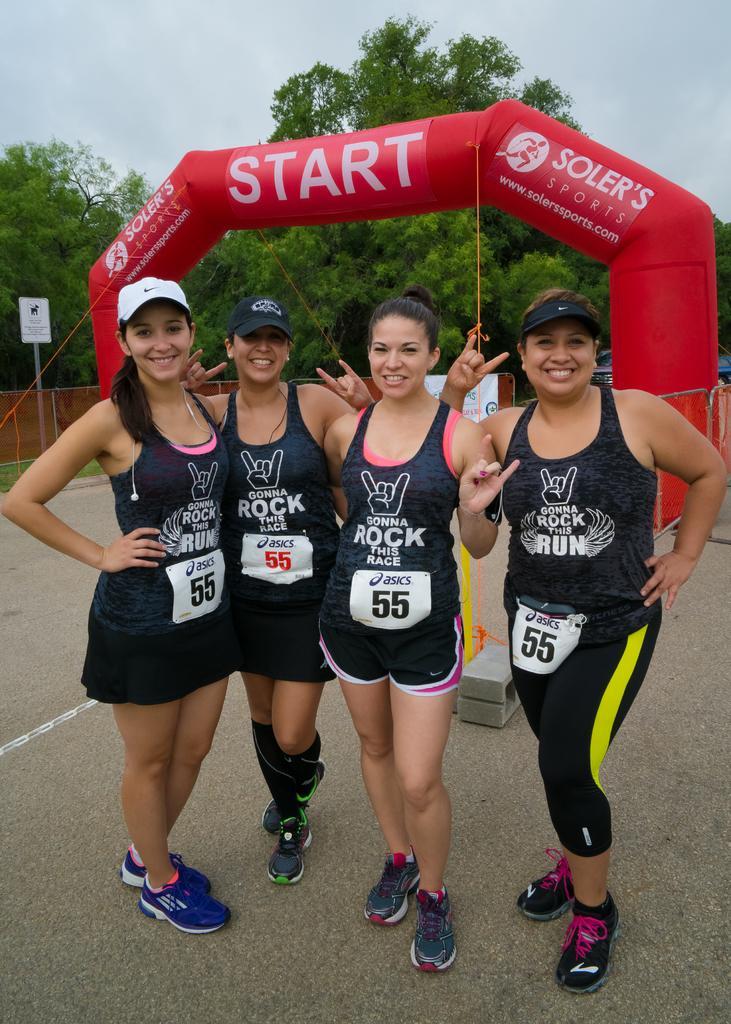Please provide a concise description of this image. In this image we can see four ladies standing. Few are wearing cap. In the back there is an arch with something written. In the background there are trees. Also there is a wall. At the top there is sky. 